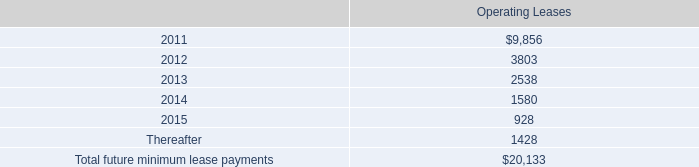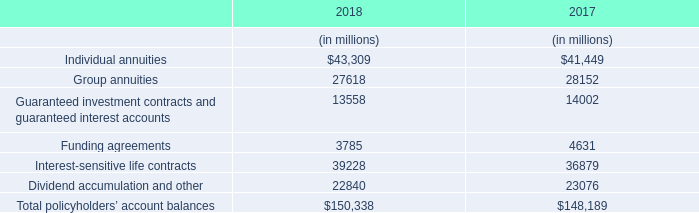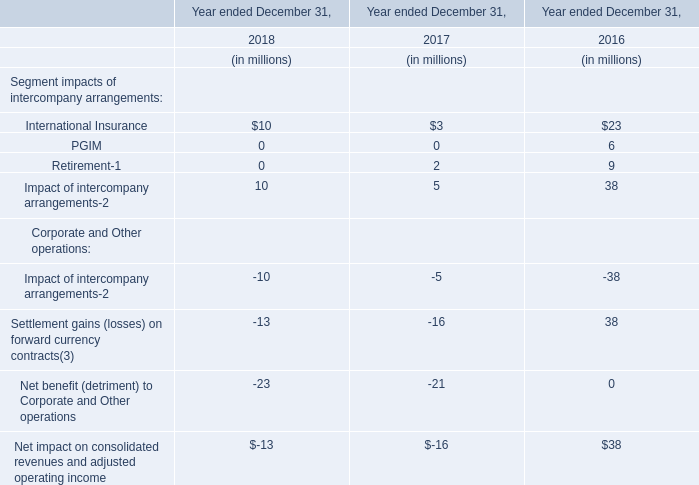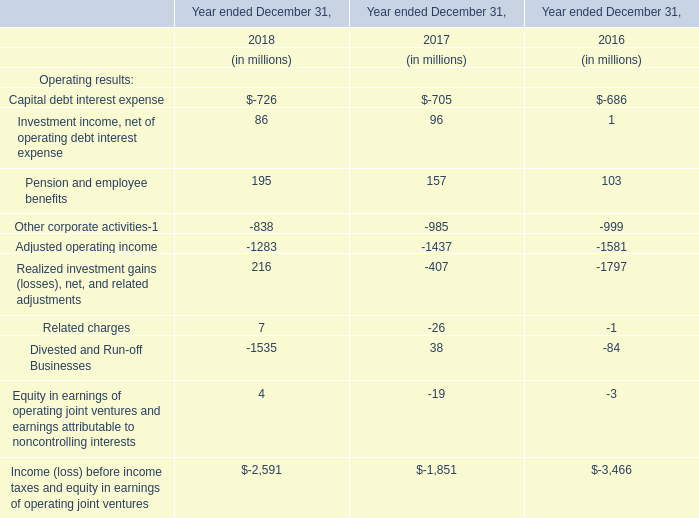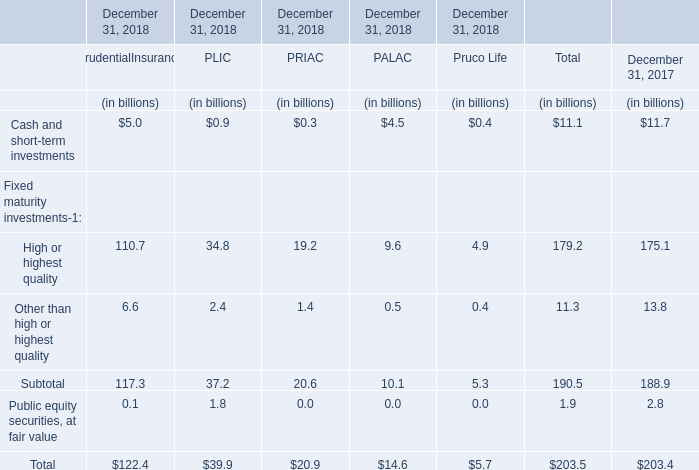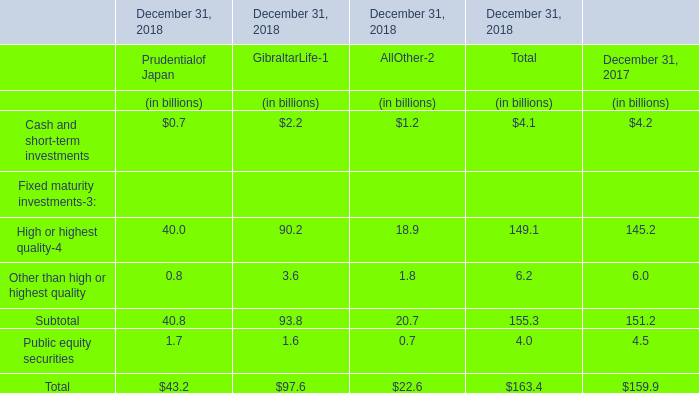What is the sum of Cash and short-term investments, High or highest quality and Other than high or highest quality in 2017? ? (in billion) 
Computations: ((11.7 + 175.1) + 13.8)
Answer: 200.6. 